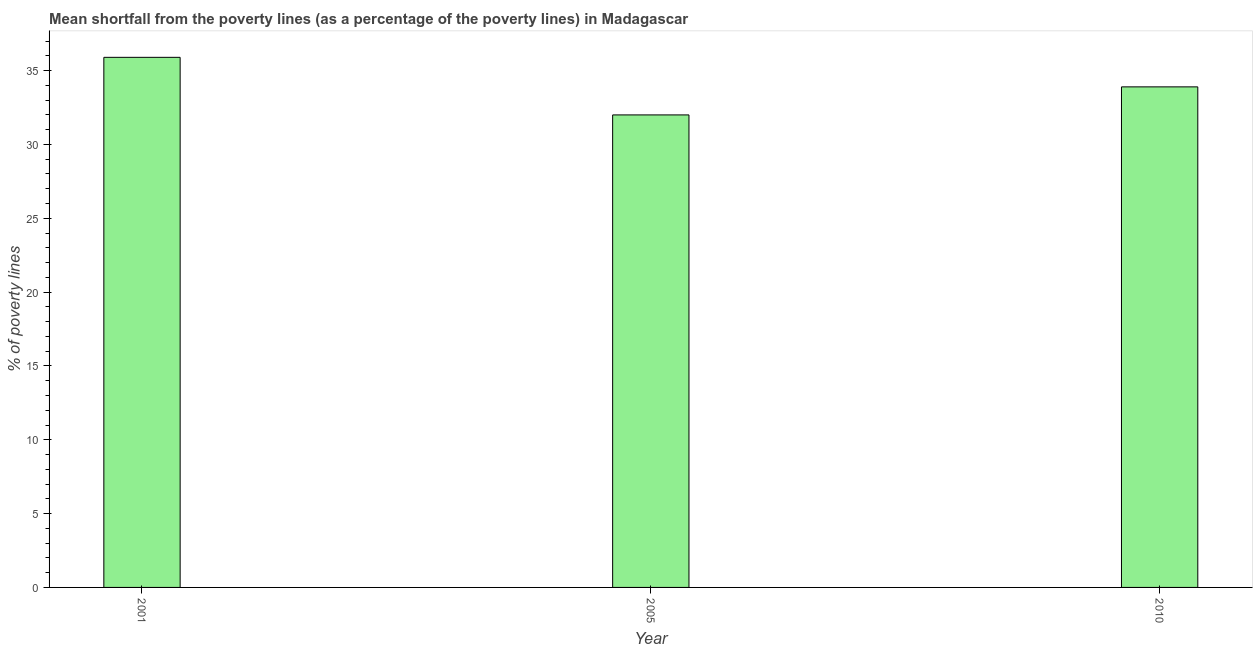Does the graph contain any zero values?
Offer a terse response. No. Does the graph contain grids?
Provide a short and direct response. No. What is the title of the graph?
Ensure brevity in your answer.  Mean shortfall from the poverty lines (as a percentage of the poverty lines) in Madagascar. What is the label or title of the X-axis?
Keep it short and to the point. Year. What is the label or title of the Y-axis?
Your response must be concise. % of poverty lines. What is the poverty gap at national poverty lines in 2001?
Offer a terse response. 35.9. Across all years, what is the maximum poverty gap at national poverty lines?
Ensure brevity in your answer.  35.9. What is the sum of the poverty gap at national poverty lines?
Keep it short and to the point. 101.8. What is the difference between the poverty gap at national poverty lines in 2001 and 2010?
Ensure brevity in your answer.  2. What is the average poverty gap at national poverty lines per year?
Your response must be concise. 33.93. What is the median poverty gap at national poverty lines?
Keep it short and to the point. 33.9. In how many years, is the poverty gap at national poverty lines greater than 11 %?
Offer a very short reply. 3. Do a majority of the years between 2010 and 2005 (inclusive) have poverty gap at national poverty lines greater than 4 %?
Offer a very short reply. No. What is the ratio of the poverty gap at national poverty lines in 2001 to that in 2005?
Ensure brevity in your answer.  1.12. Is the poverty gap at national poverty lines in 2001 less than that in 2005?
Provide a short and direct response. No. Is the difference between the poverty gap at national poverty lines in 2001 and 2010 greater than the difference between any two years?
Provide a short and direct response. No. What is the difference between the highest and the second highest poverty gap at national poverty lines?
Provide a short and direct response. 2. In how many years, is the poverty gap at national poverty lines greater than the average poverty gap at national poverty lines taken over all years?
Give a very brief answer. 1. How many bars are there?
Your answer should be very brief. 3. How many years are there in the graph?
Keep it short and to the point. 3. What is the difference between two consecutive major ticks on the Y-axis?
Keep it short and to the point. 5. Are the values on the major ticks of Y-axis written in scientific E-notation?
Your answer should be very brief. No. What is the % of poverty lines of 2001?
Your answer should be very brief. 35.9. What is the % of poverty lines in 2005?
Make the answer very short. 32. What is the % of poverty lines of 2010?
Ensure brevity in your answer.  33.9. What is the ratio of the % of poverty lines in 2001 to that in 2005?
Your answer should be very brief. 1.12. What is the ratio of the % of poverty lines in 2001 to that in 2010?
Your answer should be compact. 1.06. What is the ratio of the % of poverty lines in 2005 to that in 2010?
Keep it short and to the point. 0.94. 